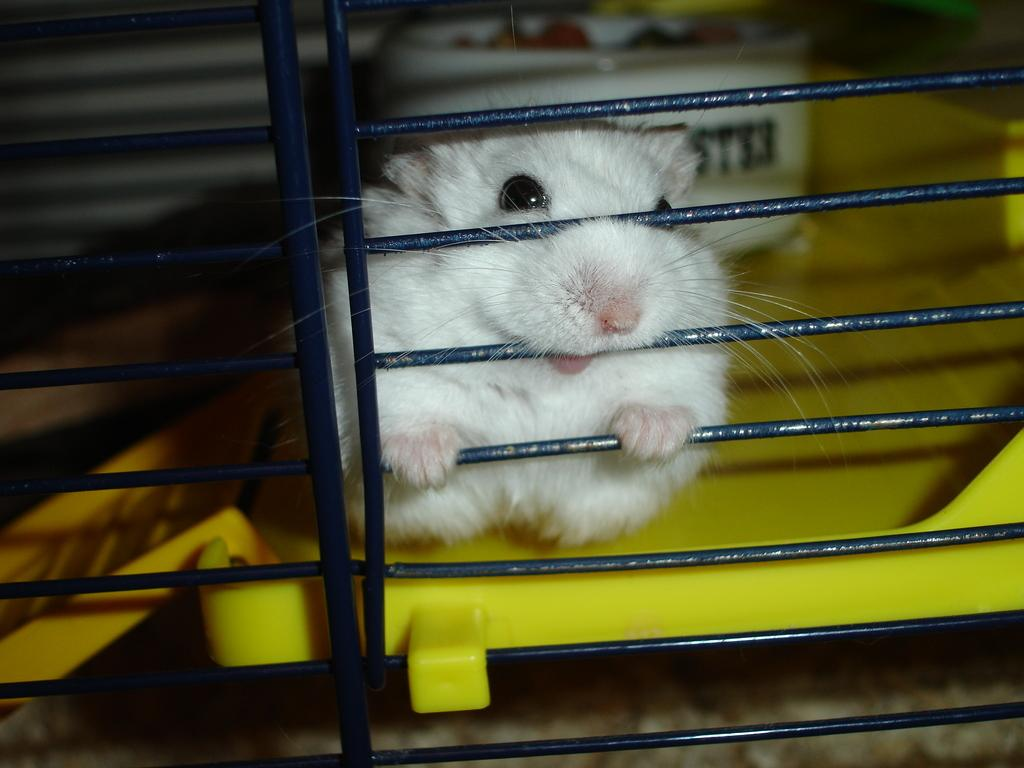What type of animal is in the image? There is a white rat in the image. Where is the rat located? The rat is inside a cage. What is the rat sitting on? The rat is sitting on a yellow plate. How many toes does the rat have in the image? It is not possible to determine the number of toes the rat has in the image, as rats have fur and not visible toes. 